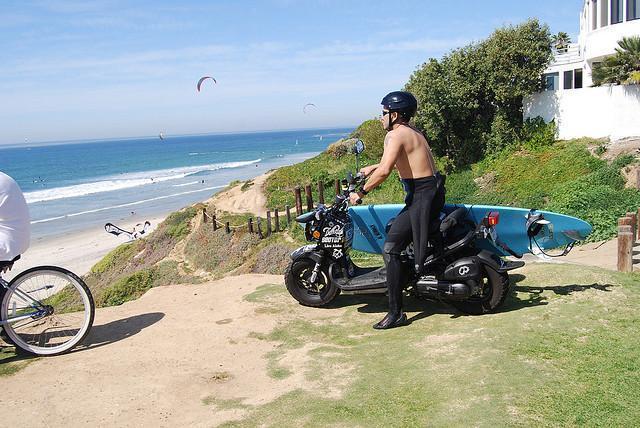How many types of bikes are there?
Give a very brief answer. 2. How many people are there?
Give a very brief answer. 2. 